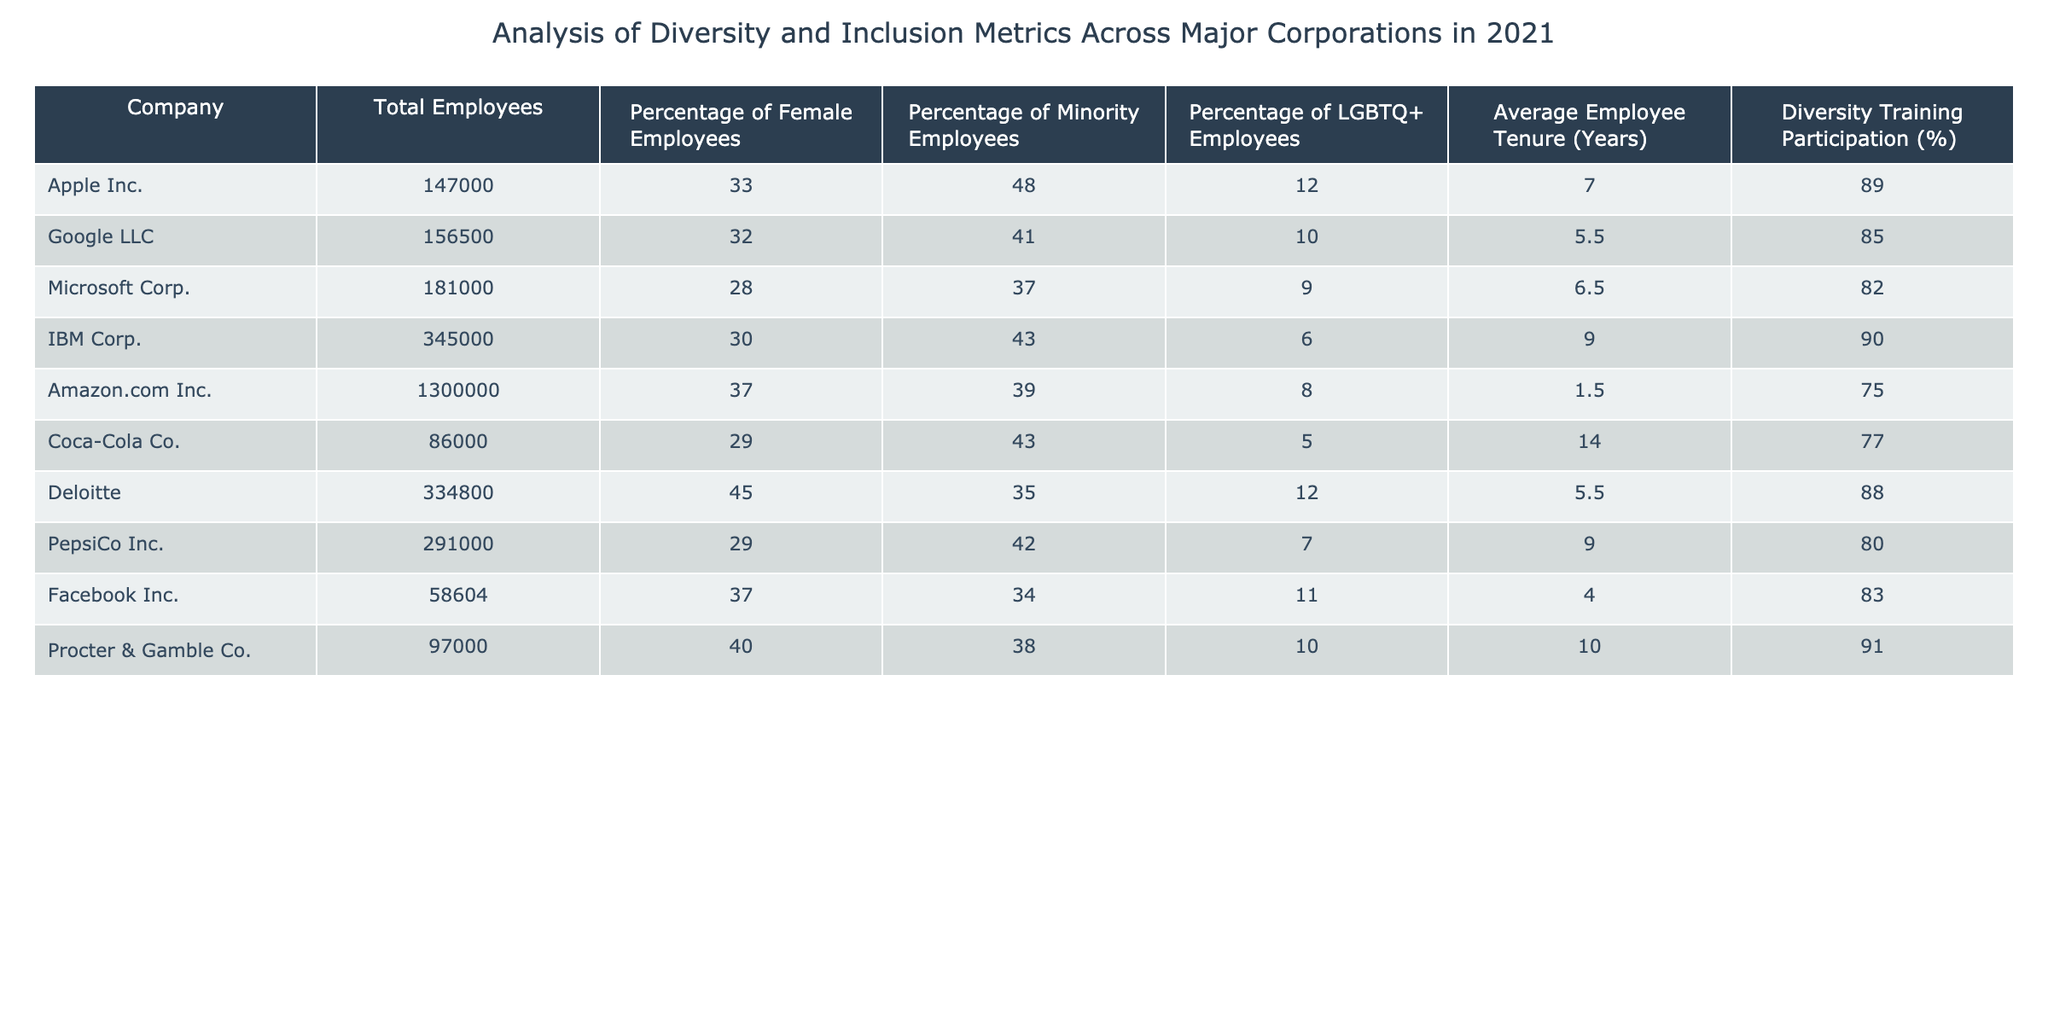What is the percentage of female employees at Apple Inc.? The table states that for Apple Inc., the percentage of female employees is listed under the relevant column as 33.
Answer: 33 Which company has the highest percentage of minority employees? By examining the "Percentage of Minority Employees" column, it can be seen that Apple Inc. has the highest value at 48%.
Answer: 48 What is the average employee tenure across all companies listed? To find the average, sum up the Average Employee Tenure (7.0 + 5.5 + 6.5 + 9.0 + 1.5 + 14.0 + 5.5 + 9.0 + 4.0 + 10.0) which totals to 68, then divide by the number of companies (10) giving an average of 6.8 years.
Answer: 6.8 Is the percentage of LGBTQ+ employees at Facebook Inc. greater than at Amazon.com Inc.? The table shows that Facebook Inc. has 11% and Amazon.com Inc. has 8%. Since 11 is greater than 8, the statement is true.
Answer: Yes What is the total number of employees across the three companies with the highest percentage of female employees? The three companies are Deloitte (334800), Procter & Gamble Co. (97000), and Apple Inc. (147000). Adding these totals together gives 334800 + 97000 + 147000 = 576800 employees in total.
Answer: 576800 Which company has the lowest participation in diversity training? Looking at the "Diversity Training Participation (%)" column, Amazon.com Inc. has the lowest at 75%.
Answer: 75 Do both IBM Corp. and Microsoft Corp. have lower than average female employees? The average percentage of female employees across the companies is 34.6% (calculated as the sum of the percentages divided by the number of companies). IBM Corp. has 30% and Microsoft Corp. has 28%, both being lower than the average. This confirms both are indeed below average.
Answer: Yes How much higher is the percentage of minority employees at IBM Corp. compared to Microsoft Corp.? From the table, IBM Corp. has 43% and Microsoft Corp. has 37%. The difference is calculated as 43 - 37 = 6%. Thus, IBM Corp's percentage of minority employees is 6% higher than that of Microsoft Corp.
Answer: 6 